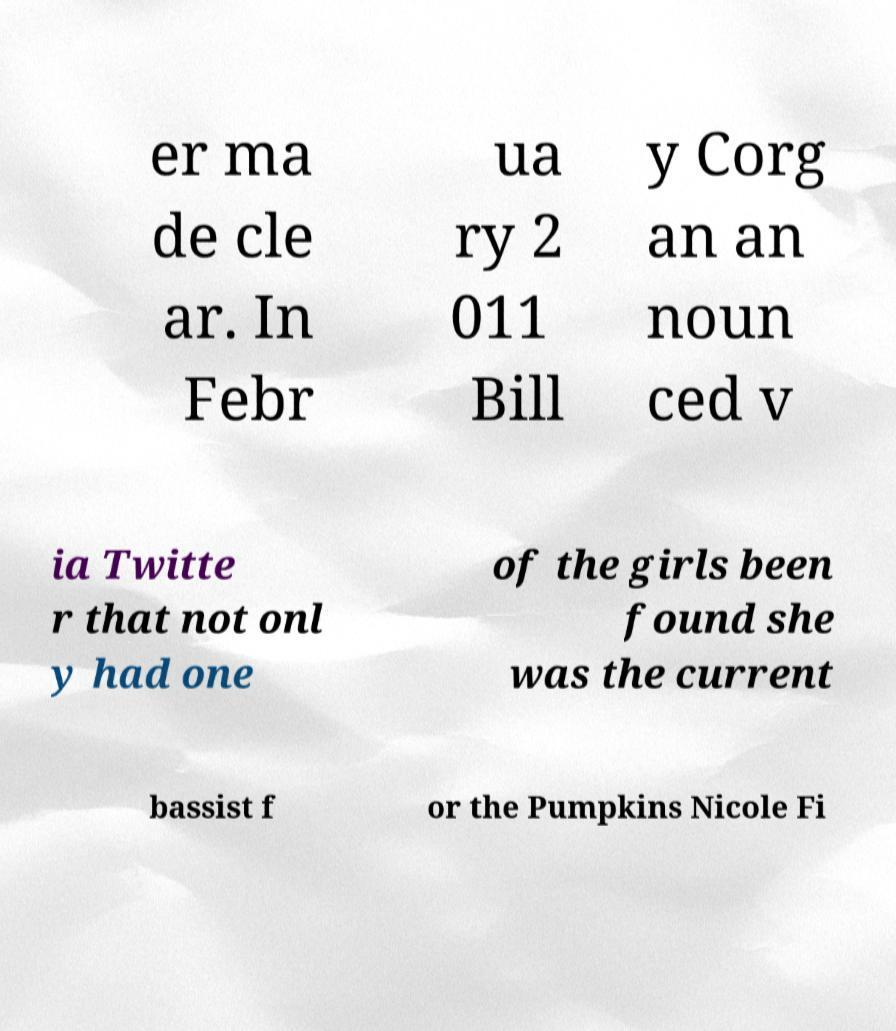Please identify and transcribe the text found in this image. er ma de cle ar. In Febr ua ry 2 011 Bill y Corg an an noun ced v ia Twitte r that not onl y had one of the girls been found she was the current bassist f or the Pumpkins Nicole Fi 